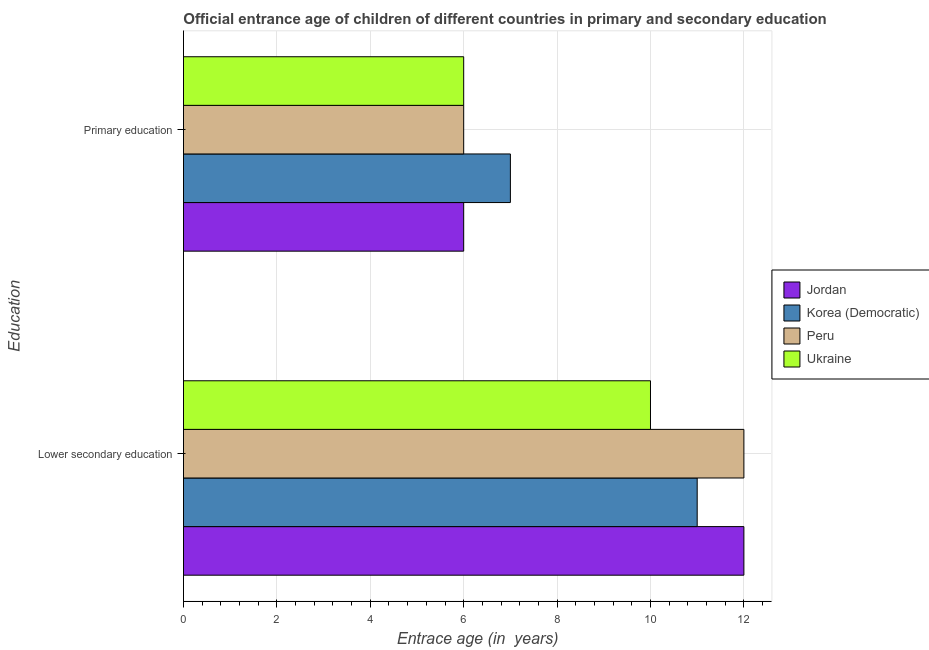How many different coloured bars are there?
Your answer should be compact. 4. Are the number of bars on each tick of the Y-axis equal?
Offer a very short reply. Yes. How many bars are there on the 1st tick from the top?
Keep it short and to the point. 4. What is the label of the 2nd group of bars from the top?
Offer a terse response. Lower secondary education. What is the entrance age of chiildren in primary education in Peru?
Your response must be concise. 6. Across all countries, what is the maximum entrance age of children in lower secondary education?
Provide a short and direct response. 12. In which country was the entrance age of children in lower secondary education maximum?
Keep it short and to the point. Jordan. In which country was the entrance age of children in lower secondary education minimum?
Keep it short and to the point. Ukraine. What is the total entrance age of children in lower secondary education in the graph?
Provide a succinct answer. 45. What is the difference between the entrance age of children in lower secondary education in Peru and that in Ukraine?
Ensure brevity in your answer.  2. What is the difference between the entrance age of children in lower secondary education in Peru and the entrance age of chiildren in primary education in Ukraine?
Your response must be concise. 6. What is the average entrance age of chiildren in primary education per country?
Offer a terse response. 6.25. What is the difference between the entrance age of children in lower secondary education and entrance age of chiildren in primary education in Ukraine?
Ensure brevity in your answer.  4. In how many countries, is the entrance age of chiildren in primary education greater than 5.6 years?
Your answer should be very brief. 4. What is the ratio of the entrance age of chiildren in primary education in Peru to that in Korea (Democratic)?
Your response must be concise. 0.86. What does the 3rd bar from the top in Primary education represents?
Your response must be concise. Korea (Democratic). What does the 4th bar from the bottom in Lower secondary education represents?
Make the answer very short. Ukraine. How many countries are there in the graph?
Keep it short and to the point. 4. Does the graph contain any zero values?
Your answer should be very brief. No. How many legend labels are there?
Your answer should be compact. 4. How are the legend labels stacked?
Keep it short and to the point. Vertical. What is the title of the graph?
Your answer should be compact. Official entrance age of children of different countries in primary and secondary education. Does "Germany" appear as one of the legend labels in the graph?
Provide a succinct answer. No. What is the label or title of the X-axis?
Provide a short and direct response. Entrace age (in  years). What is the label or title of the Y-axis?
Your answer should be very brief. Education. What is the Entrace age (in  years) of Jordan in Lower secondary education?
Your answer should be compact. 12. What is the Entrace age (in  years) in Korea (Democratic) in Lower secondary education?
Your answer should be very brief. 11. What is the Entrace age (in  years) of Peru in Lower secondary education?
Make the answer very short. 12. What is the Entrace age (in  years) of Ukraine in Lower secondary education?
Make the answer very short. 10. What is the Entrace age (in  years) in Korea (Democratic) in Primary education?
Offer a terse response. 7. What is the Entrace age (in  years) in Ukraine in Primary education?
Ensure brevity in your answer.  6. Across all Education, what is the maximum Entrace age (in  years) in Jordan?
Provide a short and direct response. 12. Across all Education, what is the maximum Entrace age (in  years) in Korea (Democratic)?
Your answer should be very brief. 11. Across all Education, what is the minimum Entrace age (in  years) of Peru?
Offer a terse response. 6. What is the total Entrace age (in  years) of Jordan in the graph?
Keep it short and to the point. 18. What is the total Entrace age (in  years) of Peru in the graph?
Offer a terse response. 18. What is the total Entrace age (in  years) in Ukraine in the graph?
Offer a terse response. 16. What is the difference between the Entrace age (in  years) in Jordan in Lower secondary education and that in Primary education?
Give a very brief answer. 6. What is the difference between the Entrace age (in  years) in Korea (Democratic) in Lower secondary education and that in Primary education?
Your answer should be compact. 4. What is the difference between the Entrace age (in  years) of Peru in Lower secondary education and that in Primary education?
Offer a terse response. 6. What is the difference between the Entrace age (in  years) in Ukraine in Lower secondary education and that in Primary education?
Your answer should be compact. 4. What is the difference between the Entrace age (in  years) in Jordan in Lower secondary education and the Entrace age (in  years) in Ukraine in Primary education?
Give a very brief answer. 6. What is the difference between the Entrace age (in  years) in Korea (Democratic) in Lower secondary education and the Entrace age (in  years) in Ukraine in Primary education?
Provide a short and direct response. 5. What is the average Entrace age (in  years) of Jordan per Education?
Offer a very short reply. 9. What is the average Entrace age (in  years) of Peru per Education?
Your response must be concise. 9. What is the difference between the Entrace age (in  years) in Korea (Democratic) and Entrace age (in  years) in Ukraine in Lower secondary education?
Your answer should be compact. 1. What is the difference between the Entrace age (in  years) of Jordan and Entrace age (in  years) of Korea (Democratic) in Primary education?
Your response must be concise. -1. What is the difference between the Entrace age (in  years) of Jordan and Entrace age (in  years) of Peru in Primary education?
Provide a short and direct response. 0. What is the difference between the Entrace age (in  years) of Korea (Democratic) and Entrace age (in  years) of Ukraine in Primary education?
Keep it short and to the point. 1. What is the ratio of the Entrace age (in  years) in Korea (Democratic) in Lower secondary education to that in Primary education?
Ensure brevity in your answer.  1.57. What is the difference between the highest and the second highest Entrace age (in  years) in Jordan?
Keep it short and to the point. 6. What is the difference between the highest and the second highest Entrace age (in  years) of Peru?
Your answer should be compact. 6. What is the difference between the highest and the lowest Entrace age (in  years) of Korea (Democratic)?
Your answer should be very brief. 4. What is the difference between the highest and the lowest Entrace age (in  years) in Ukraine?
Give a very brief answer. 4. 